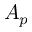<formula> <loc_0><loc_0><loc_500><loc_500>A _ { p }</formula> 